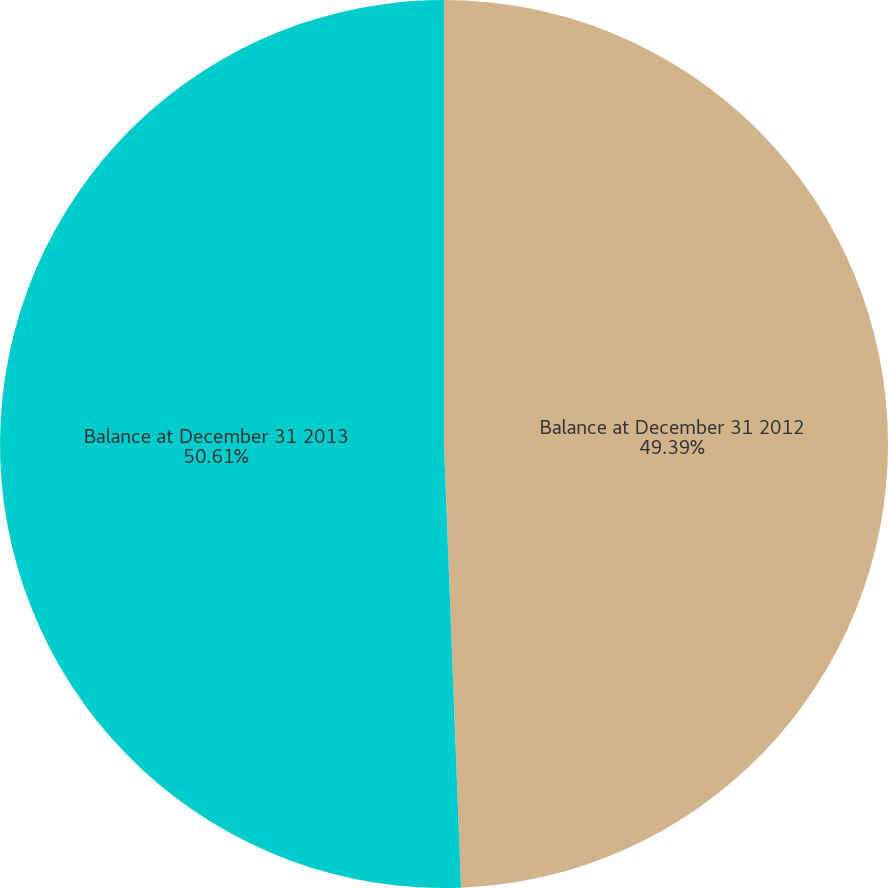<chart> <loc_0><loc_0><loc_500><loc_500><pie_chart><fcel>Balance at December 31 2012<fcel>Balance at December 31 2013<nl><fcel>49.39%<fcel>50.61%<nl></chart> 